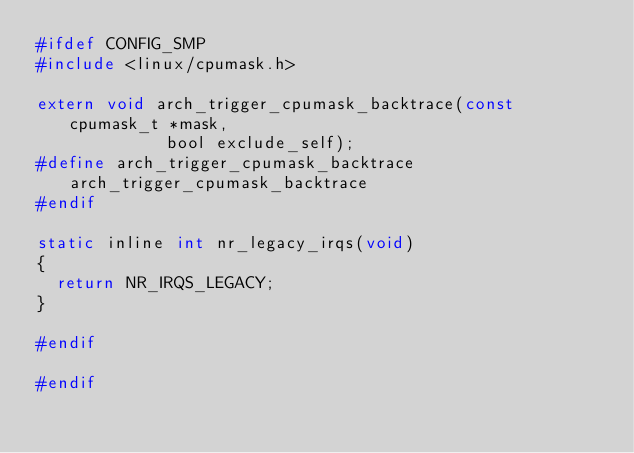<code> <loc_0><loc_0><loc_500><loc_500><_C_>#ifdef CONFIG_SMP
#include <linux/cpumask.h>

extern void arch_trigger_cpumask_backtrace(const cpumask_t *mask,
					   bool exclude_self);
#define arch_trigger_cpumask_backtrace arch_trigger_cpumask_backtrace
#endif

static inline int nr_legacy_irqs(void)
{
	return NR_IRQS_LEGACY;
}

#endif

#endif

</code> 